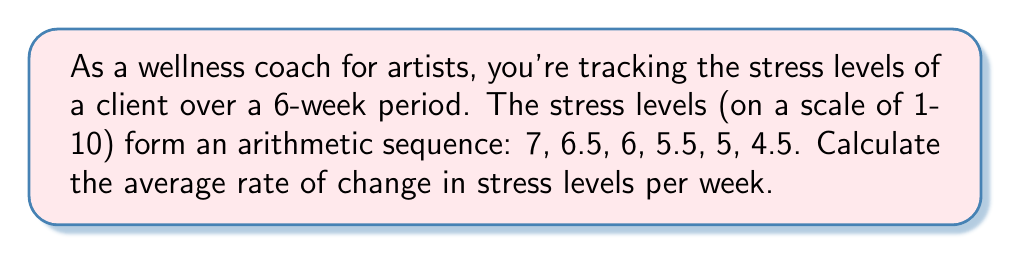Can you solve this math problem? To solve this problem, we'll follow these steps:

1) First, let's identify the arithmetic sequence:
   $a_1 = 7, a_2 = 6.5, a_3 = 6, a_4 = 5.5, a_5 = 5, a_6 = 4.5$

2) In an arithmetic sequence, the difference between any two consecutive terms is constant. Let's call this common difference $d$. We can calculate it:

   $d = a_2 - a_1 = 6.5 - 7 = -0.5$

3) The negative value indicates that the stress levels are decreasing over time.

4) To find the average rate of change, we need to calculate the total change in stress levels and divide it by the number of weeks:

   Total change = $a_6 - a_1 = 4.5 - 7 = -2.5$

   Number of weeks = 6

5) Average rate of change = $\frac{\text{Total change}}{\text{Number of weeks}}$

   $= \frac{-2.5}{6} = -\frac{5}{12} \approx -0.4167$

Therefore, the average rate of change in stress levels is $-\frac{5}{12}$ or approximately -0.4167 units per week.
Answer: $-\frac{5}{12}$ units per week 